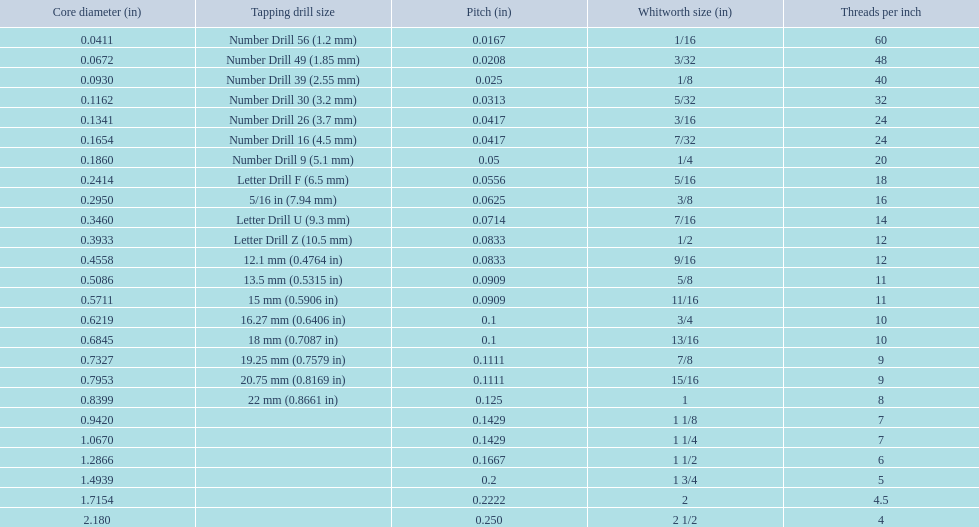What was the core diameter of a number drill 26 0.1341. What is this measurement in whitworth size? 3/16. 